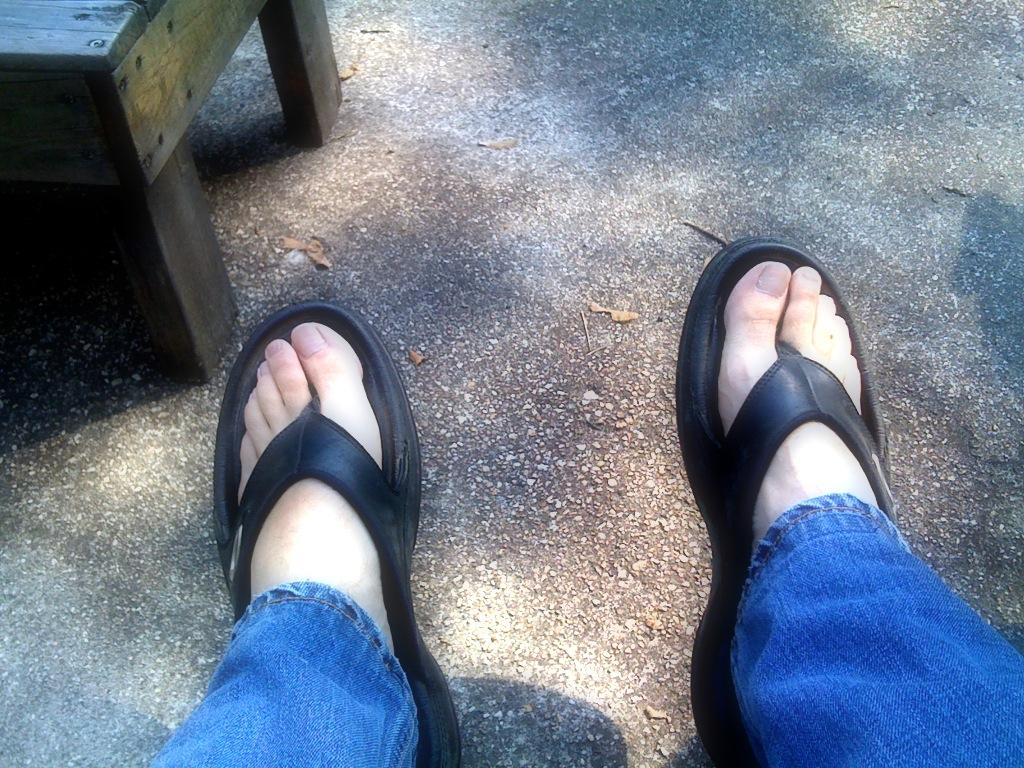What type of clothing is the person wearing on their legs in the image? The person is wearing blue jeans in the image. What type of footwear is the person wearing in the image? The person is wearing black slippers in the image. Can you describe the wooden object in the image? There is a wooden object in the top left side of the image. What is the reaction of the ladybug to the person's slippers in the image? There is no ladybug present in the image, so it is not possible to determine its reaction to the person's slippers. 